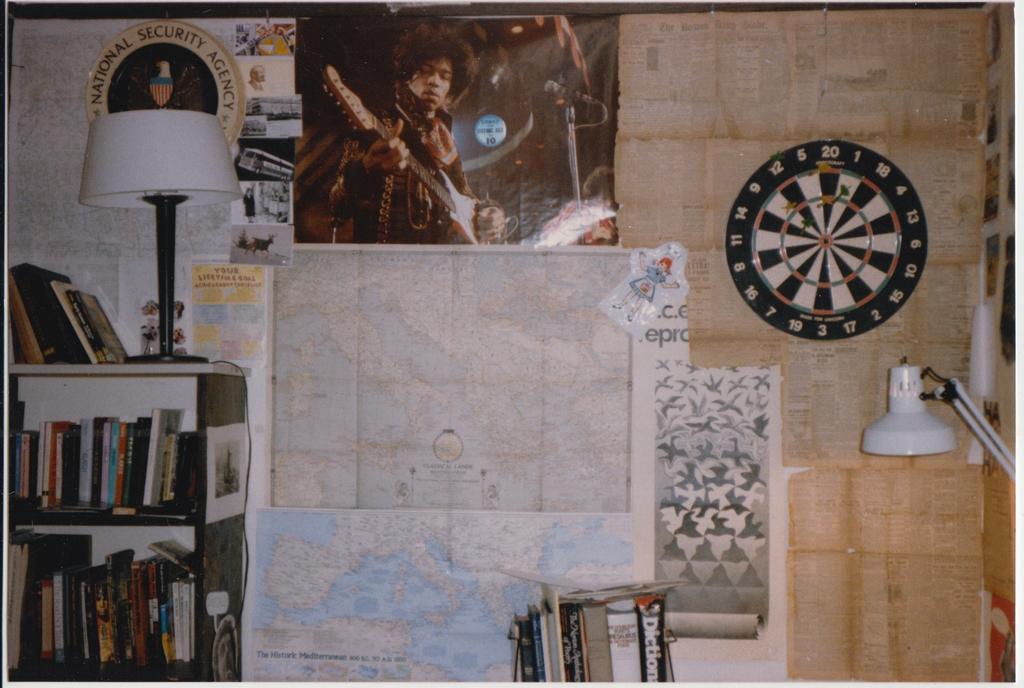Could you give a brief overview of what you see in this image? In this image, I can see the maps, posters, sticker, papers and a dartboard are attached to an object. On the left side of the image, I can see the books in a rack and there is a lamp on a rack. At the bottom of the image, I can see few books. On the right side of the image, It looks like a study lamp. 